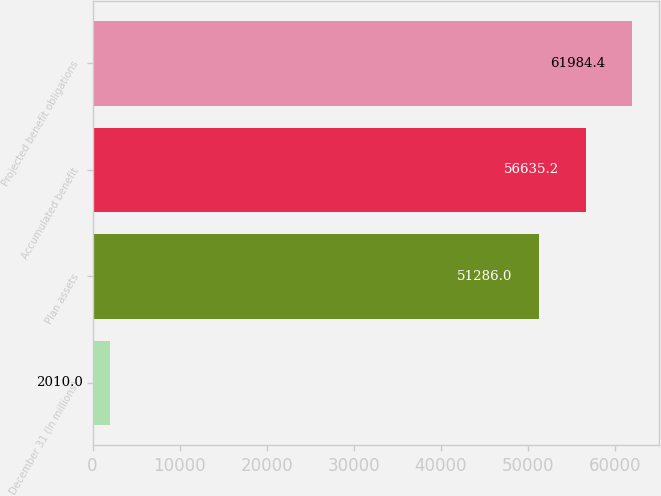<chart> <loc_0><loc_0><loc_500><loc_500><bar_chart><fcel>December 31 (In millions)<fcel>Plan assets<fcel>Accumulated benefit<fcel>Projected benefit obligations<nl><fcel>2010<fcel>51286<fcel>56635.2<fcel>61984.4<nl></chart> 